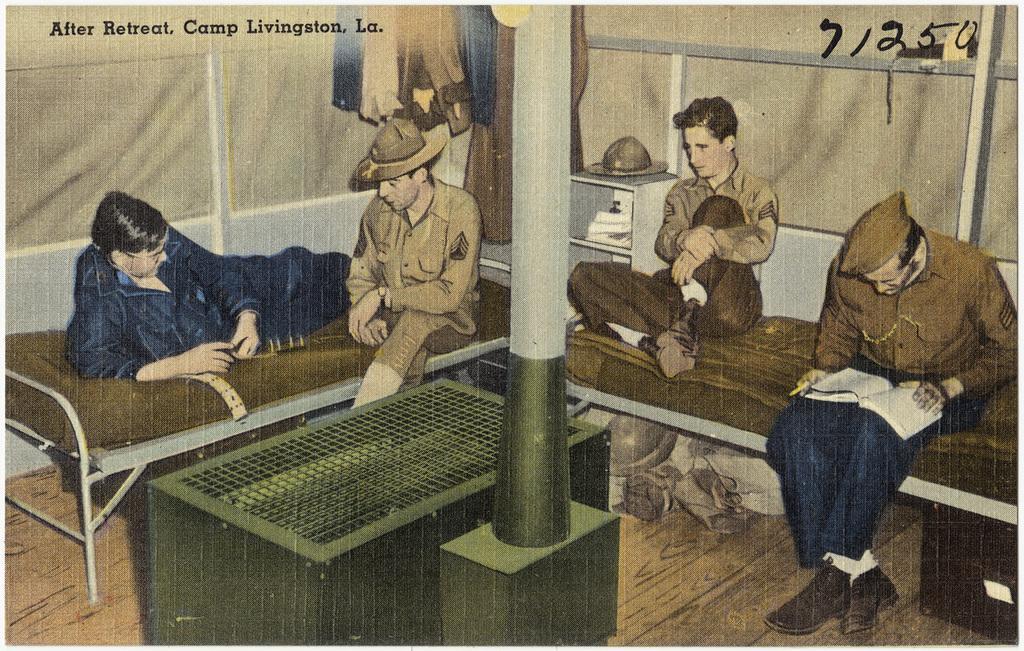In one or two sentences, can you explain what this image depicts? It is a poster. In the poster there is a pole. Behind the pole there are some beds, on the beds few people are sitting and holding something. Behind them there is wall and clothes. 